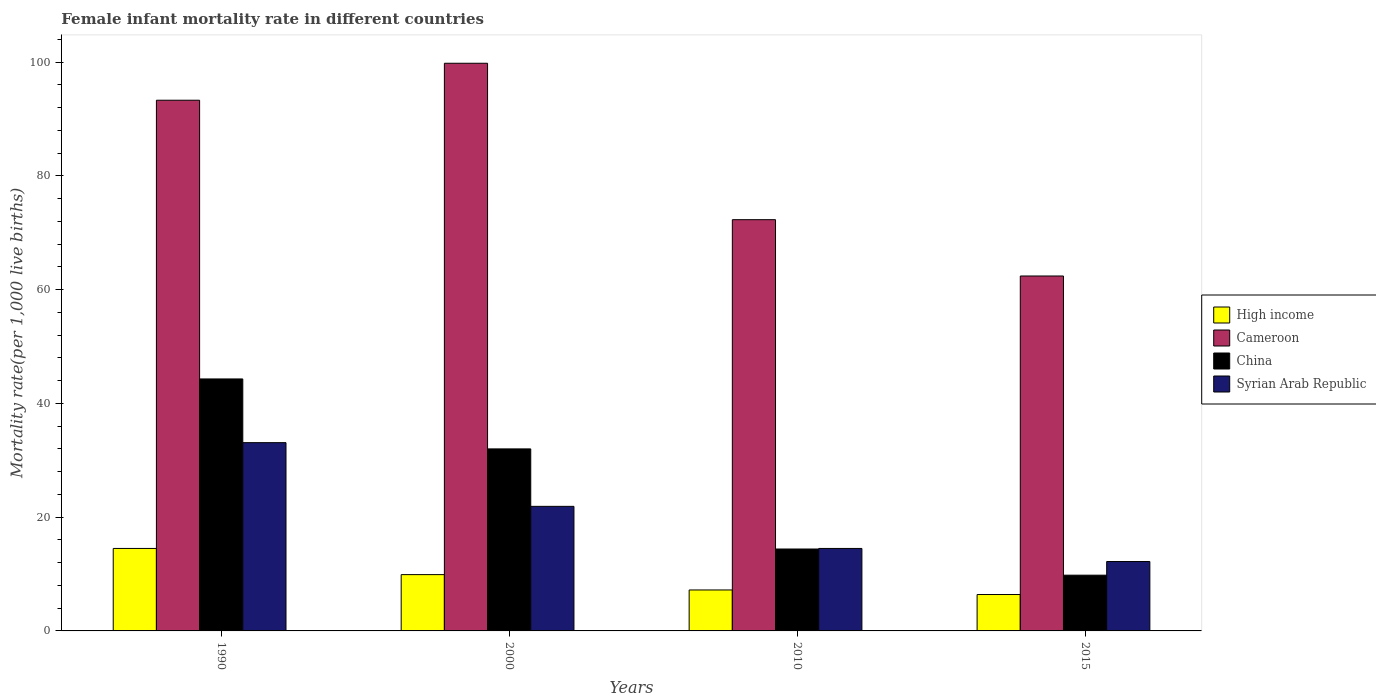Are the number of bars on each tick of the X-axis equal?
Offer a terse response. Yes. In how many cases, is the number of bars for a given year not equal to the number of legend labels?
Offer a very short reply. 0. Across all years, what is the minimum female infant mortality rate in Cameroon?
Provide a succinct answer. 62.4. In which year was the female infant mortality rate in High income minimum?
Give a very brief answer. 2015. What is the total female infant mortality rate in Syrian Arab Republic in the graph?
Provide a short and direct response. 81.7. What is the difference between the female infant mortality rate in High income in 2000 and the female infant mortality rate in Syrian Arab Republic in 1990?
Provide a succinct answer. -23.2. What is the average female infant mortality rate in Cameroon per year?
Give a very brief answer. 81.95. In the year 2000, what is the difference between the female infant mortality rate in China and female infant mortality rate in Syrian Arab Republic?
Ensure brevity in your answer.  10.1. In how many years, is the female infant mortality rate in Cameroon greater than 60?
Your answer should be very brief. 4. What is the ratio of the female infant mortality rate in China in 1990 to that in 2015?
Your answer should be compact. 4.52. Is the female infant mortality rate in Cameroon in 1990 less than that in 2010?
Your answer should be compact. No. What is the difference between the highest and the second highest female infant mortality rate in China?
Offer a very short reply. 12.3. What is the difference between the highest and the lowest female infant mortality rate in China?
Make the answer very short. 34.5. In how many years, is the female infant mortality rate in Cameroon greater than the average female infant mortality rate in Cameroon taken over all years?
Offer a terse response. 2. Is the sum of the female infant mortality rate in High income in 2000 and 2010 greater than the maximum female infant mortality rate in Syrian Arab Republic across all years?
Your response must be concise. No. Is it the case that in every year, the sum of the female infant mortality rate in Syrian Arab Republic and female infant mortality rate in High income is greater than the sum of female infant mortality rate in China and female infant mortality rate in Cameroon?
Your response must be concise. No. What does the 1st bar from the left in 2010 represents?
Your answer should be very brief. High income. Is it the case that in every year, the sum of the female infant mortality rate in High income and female infant mortality rate in Cameroon is greater than the female infant mortality rate in Syrian Arab Republic?
Ensure brevity in your answer.  Yes. Are all the bars in the graph horizontal?
Keep it short and to the point. No. How many years are there in the graph?
Provide a succinct answer. 4. What is the difference between two consecutive major ticks on the Y-axis?
Your answer should be compact. 20. Where does the legend appear in the graph?
Give a very brief answer. Center right. How are the legend labels stacked?
Provide a succinct answer. Vertical. What is the title of the graph?
Offer a terse response. Female infant mortality rate in different countries. Does "Lesotho" appear as one of the legend labels in the graph?
Keep it short and to the point. No. What is the label or title of the Y-axis?
Your response must be concise. Mortality rate(per 1,0 live births). What is the Mortality rate(per 1,000 live births) of Cameroon in 1990?
Offer a very short reply. 93.3. What is the Mortality rate(per 1,000 live births) of China in 1990?
Ensure brevity in your answer.  44.3. What is the Mortality rate(per 1,000 live births) of Syrian Arab Republic in 1990?
Your response must be concise. 33.1. What is the Mortality rate(per 1,000 live births) in High income in 2000?
Your answer should be compact. 9.9. What is the Mortality rate(per 1,000 live births) in Cameroon in 2000?
Make the answer very short. 99.8. What is the Mortality rate(per 1,000 live births) of China in 2000?
Keep it short and to the point. 32. What is the Mortality rate(per 1,000 live births) of Syrian Arab Republic in 2000?
Keep it short and to the point. 21.9. What is the Mortality rate(per 1,000 live births) of Cameroon in 2010?
Offer a very short reply. 72.3. What is the Mortality rate(per 1,000 live births) of China in 2010?
Give a very brief answer. 14.4. What is the Mortality rate(per 1,000 live births) in Cameroon in 2015?
Your response must be concise. 62.4. What is the Mortality rate(per 1,000 live births) of Syrian Arab Republic in 2015?
Offer a very short reply. 12.2. Across all years, what is the maximum Mortality rate(per 1,000 live births) of Cameroon?
Keep it short and to the point. 99.8. Across all years, what is the maximum Mortality rate(per 1,000 live births) of China?
Keep it short and to the point. 44.3. Across all years, what is the maximum Mortality rate(per 1,000 live births) in Syrian Arab Republic?
Offer a very short reply. 33.1. Across all years, what is the minimum Mortality rate(per 1,000 live births) in Cameroon?
Offer a terse response. 62.4. Across all years, what is the minimum Mortality rate(per 1,000 live births) in China?
Your response must be concise. 9.8. What is the total Mortality rate(per 1,000 live births) in Cameroon in the graph?
Your response must be concise. 327.8. What is the total Mortality rate(per 1,000 live births) of China in the graph?
Provide a short and direct response. 100.5. What is the total Mortality rate(per 1,000 live births) of Syrian Arab Republic in the graph?
Ensure brevity in your answer.  81.7. What is the difference between the Mortality rate(per 1,000 live births) of Cameroon in 1990 and that in 2000?
Provide a succinct answer. -6.5. What is the difference between the Mortality rate(per 1,000 live births) of Syrian Arab Republic in 1990 and that in 2000?
Your response must be concise. 11.2. What is the difference between the Mortality rate(per 1,000 live births) of Cameroon in 1990 and that in 2010?
Ensure brevity in your answer.  21. What is the difference between the Mortality rate(per 1,000 live births) in China in 1990 and that in 2010?
Provide a succinct answer. 29.9. What is the difference between the Mortality rate(per 1,000 live births) in High income in 1990 and that in 2015?
Your response must be concise. 8.1. What is the difference between the Mortality rate(per 1,000 live births) in Cameroon in 1990 and that in 2015?
Your response must be concise. 30.9. What is the difference between the Mortality rate(per 1,000 live births) of China in 1990 and that in 2015?
Your answer should be compact. 34.5. What is the difference between the Mortality rate(per 1,000 live births) of Syrian Arab Republic in 1990 and that in 2015?
Provide a short and direct response. 20.9. What is the difference between the Mortality rate(per 1,000 live births) of High income in 2000 and that in 2010?
Provide a succinct answer. 2.7. What is the difference between the Mortality rate(per 1,000 live births) of Syrian Arab Republic in 2000 and that in 2010?
Your response must be concise. 7.4. What is the difference between the Mortality rate(per 1,000 live births) of High income in 2000 and that in 2015?
Provide a succinct answer. 3.5. What is the difference between the Mortality rate(per 1,000 live births) in Cameroon in 2000 and that in 2015?
Your answer should be very brief. 37.4. What is the difference between the Mortality rate(per 1,000 live births) in China in 2000 and that in 2015?
Ensure brevity in your answer.  22.2. What is the difference between the Mortality rate(per 1,000 live births) in Syrian Arab Republic in 2000 and that in 2015?
Your response must be concise. 9.7. What is the difference between the Mortality rate(per 1,000 live births) of High income in 2010 and that in 2015?
Provide a succinct answer. 0.8. What is the difference between the Mortality rate(per 1,000 live births) in Cameroon in 2010 and that in 2015?
Keep it short and to the point. 9.9. What is the difference between the Mortality rate(per 1,000 live births) in China in 2010 and that in 2015?
Give a very brief answer. 4.6. What is the difference between the Mortality rate(per 1,000 live births) in Syrian Arab Republic in 2010 and that in 2015?
Keep it short and to the point. 2.3. What is the difference between the Mortality rate(per 1,000 live births) in High income in 1990 and the Mortality rate(per 1,000 live births) in Cameroon in 2000?
Your response must be concise. -85.3. What is the difference between the Mortality rate(per 1,000 live births) in High income in 1990 and the Mortality rate(per 1,000 live births) in China in 2000?
Your response must be concise. -17.5. What is the difference between the Mortality rate(per 1,000 live births) in High income in 1990 and the Mortality rate(per 1,000 live births) in Syrian Arab Republic in 2000?
Make the answer very short. -7.4. What is the difference between the Mortality rate(per 1,000 live births) of Cameroon in 1990 and the Mortality rate(per 1,000 live births) of China in 2000?
Provide a short and direct response. 61.3. What is the difference between the Mortality rate(per 1,000 live births) in Cameroon in 1990 and the Mortality rate(per 1,000 live births) in Syrian Arab Republic in 2000?
Offer a terse response. 71.4. What is the difference between the Mortality rate(per 1,000 live births) in China in 1990 and the Mortality rate(per 1,000 live births) in Syrian Arab Republic in 2000?
Provide a short and direct response. 22.4. What is the difference between the Mortality rate(per 1,000 live births) in High income in 1990 and the Mortality rate(per 1,000 live births) in Cameroon in 2010?
Your answer should be compact. -57.8. What is the difference between the Mortality rate(per 1,000 live births) of High income in 1990 and the Mortality rate(per 1,000 live births) of Syrian Arab Republic in 2010?
Offer a very short reply. 0. What is the difference between the Mortality rate(per 1,000 live births) in Cameroon in 1990 and the Mortality rate(per 1,000 live births) in China in 2010?
Your answer should be compact. 78.9. What is the difference between the Mortality rate(per 1,000 live births) of Cameroon in 1990 and the Mortality rate(per 1,000 live births) of Syrian Arab Republic in 2010?
Ensure brevity in your answer.  78.8. What is the difference between the Mortality rate(per 1,000 live births) of China in 1990 and the Mortality rate(per 1,000 live births) of Syrian Arab Republic in 2010?
Provide a short and direct response. 29.8. What is the difference between the Mortality rate(per 1,000 live births) in High income in 1990 and the Mortality rate(per 1,000 live births) in Cameroon in 2015?
Offer a very short reply. -47.9. What is the difference between the Mortality rate(per 1,000 live births) of Cameroon in 1990 and the Mortality rate(per 1,000 live births) of China in 2015?
Offer a very short reply. 83.5. What is the difference between the Mortality rate(per 1,000 live births) in Cameroon in 1990 and the Mortality rate(per 1,000 live births) in Syrian Arab Republic in 2015?
Offer a very short reply. 81.1. What is the difference between the Mortality rate(per 1,000 live births) in China in 1990 and the Mortality rate(per 1,000 live births) in Syrian Arab Republic in 2015?
Your response must be concise. 32.1. What is the difference between the Mortality rate(per 1,000 live births) in High income in 2000 and the Mortality rate(per 1,000 live births) in Cameroon in 2010?
Offer a terse response. -62.4. What is the difference between the Mortality rate(per 1,000 live births) in High income in 2000 and the Mortality rate(per 1,000 live births) in China in 2010?
Offer a very short reply. -4.5. What is the difference between the Mortality rate(per 1,000 live births) in High income in 2000 and the Mortality rate(per 1,000 live births) in Syrian Arab Republic in 2010?
Your answer should be very brief. -4.6. What is the difference between the Mortality rate(per 1,000 live births) in Cameroon in 2000 and the Mortality rate(per 1,000 live births) in China in 2010?
Offer a very short reply. 85.4. What is the difference between the Mortality rate(per 1,000 live births) in Cameroon in 2000 and the Mortality rate(per 1,000 live births) in Syrian Arab Republic in 2010?
Your response must be concise. 85.3. What is the difference between the Mortality rate(per 1,000 live births) in China in 2000 and the Mortality rate(per 1,000 live births) in Syrian Arab Republic in 2010?
Your answer should be compact. 17.5. What is the difference between the Mortality rate(per 1,000 live births) of High income in 2000 and the Mortality rate(per 1,000 live births) of Cameroon in 2015?
Your answer should be compact. -52.5. What is the difference between the Mortality rate(per 1,000 live births) of High income in 2000 and the Mortality rate(per 1,000 live births) of Syrian Arab Republic in 2015?
Provide a short and direct response. -2.3. What is the difference between the Mortality rate(per 1,000 live births) in Cameroon in 2000 and the Mortality rate(per 1,000 live births) in China in 2015?
Provide a short and direct response. 90. What is the difference between the Mortality rate(per 1,000 live births) of Cameroon in 2000 and the Mortality rate(per 1,000 live births) of Syrian Arab Republic in 2015?
Provide a short and direct response. 87.6. What is the difference between the Mortality rate(per 1,000 live births) of China in 2000 and the Mortality rate(per 1,000 live births) of Syrian Arab Republic in 2015?
Your answer should be compact. 19.8. What is the difference between the Mortality rate(per 1,000 live births) of High income in 2010 and the Mortality rate(per 1,000 live births) of Cameroon in 2015?
Provide a short and direct response. -55.2. What is the difference between the Mortality rate(per 1,000 live births) in High income in 2010 and the Mortality rate(per 1,000 live births) in China in 2015?
Provide a short and direct response. -2.6. What is the difference between the Mortality rate(per 1,000 live births) of Cameroon in 2010 and the Mortality rate(per 1,000 live births) of China in 2015?
Your answer should be very brief. 62.5. What is the difference between the Mortality rate(per 1,000 live births) in Cameroon in 2010 and the Mortality rate(per 1,000 live births) in Syrian Arab Republic in 2015?
Your answer should be compact. 60.1. What is the difference between the Mortality rate(per 1,000 live births) in China in 2010 and the Mortality rate(per 1,000 live births) in Syrian Arab Republic in 2015?
Your response must be concise. 2.2. What is the average Mortality rate(per 1,000 live births) in High income per year?
Offer a terse response. 9.5. What is the average Mortality rate(per 1,000 live births) of Cameroon per year?
Offer a terse response. 81.95. What is the average Mortality rate(per 1,000 live births) in China per year?
Keep it short and to the point. 25.12. What is the average Mortality rate(per 1,000 live births) of Syrian Arab Republic per year?
Your answer should be compact. 20.43. In the year 1990, what is the difference between the Mortality rate(per 1,000 live births) of High income and Mortality rate(per 1,000 live births) of Cameroon?
Provide a succinct answer. -78.8. In the year 1990, what is the difference between the Mortality rate(per 1,000 live births) in High income and Mortality rate(per 1,000 live births) in China?
Provide a short and direct response. -29.8. In the year 1990, what is the difference between the Mortality rate(per 1,000 live births) of High income and Mortality rate(per 1,000 live births) of Syrian Arab Republic?
Provide a succinct answer. -18.6. In the year 1990, what is the difference between the Mortality rate(per 1,000 live births) of Cameroon and Mortality rate(per 1,000 live births) of Syrian Arab Republic?
Make the answer very short. 60.2. In the year 2000, what is the difference between the Mortality rate(per 1,000 live births) in High income and Mortality rate(per 1,000 live births) in Cameroon?
Offer a very short reply. -89.9. In the year 2000, what is the difference between the Mortality rate(per 1,000 live births) in High income and Mortality rate(per 1,000 live births) in China?
Offer a terse response. -22.1. In the year 2000, what is the difference between the Mortality rate(per 1,000 live births) in Cameroon and Mortality rate(per 1,000 live births) in China?
Your response must be concise. 67.8. In the year 2000, what is the difference between the Mortality rate(per 1,000 live births) of Cameroon and Mortality rate(per 1,000 live births) of Syrian Arab Republic?
Ensure brevity in your answer.  77.9. In the year 2000, what is the difference between the Mortality rate(per 1,000 live births) in China and Mortality rate(per 1,000 live births) in Syrian Arab Republic?
Provide a short and direct response. 10.1. In the year 2010, what is the difference between the Mortality rate(per 1,000 live births) of High income and Mortality rate(per 1,000 live births) of Cameroon?
Ensure brevity in your answer.  -65.1. In the year 2010, what is the difference between the Mortality rate(per 1,000 live births) in Cameroon and Mortality rate(per 1,000 live births) in China?
Your answer should be compact. 57.9. In the year 2010, what is the difference between the Mortality rate(per 1,000 live births) of Cameroon and Mortality rate(per 1,000 live births) of Syrian Arab Republic?
Your answer should be very brief. 57.8. In the year 2010, what is the difference between the Mortality rate(per 1,000 live births) in China and Mortality rate(per 1,000 live births) in Syrian Arab Republic?
Your answer should be compact. -0.1. In the year 2015, what is the difference between the Mortality rate(per 1,000 live births) in High income and Mortality rate(per 1,000 live births) in Cameroon?
Make the answer very short. -56. In the year 2015, what is the difference between the Mortality rate(per 1,000 live births) in Cameroon and Mortality rate(per 1,000 live births) in China?
Offer a very short reply. 52.6. In the year 2015, what is the difference between the Mortality rate(per 1,000 live births) of Cameroon and Mortality rate(per 1,000 live births) of Syrian Arab Republic?
Ensure brevity in your answer.  50.2. In the year 2015, what is the difference between the Mortality rate(per 1,000 live births) in China and Mortality rate(per 1,000 live births) in Syrian Arab Republic?
Give a very brief answer. -2.4. What is the ratio of the Mortality rate(per 1,000 live births) in High income in 1990 to that in 2000?
Provide a short and direct response. 1.46. What is the ratio of the Mortality rate(per 1,000 live births) in Cameroon in 1990 to that in 2000?
Offer a very short reply. 0.93. What is the ratio of the Mortality rate(per 1,000 live births) in China in 1990 to that in 2000?
Your answer should be compact. 1.38. What is the ratio of the Mortality rate(per 1,000 live births) in Syrian Arab Republic in 1990 to that in 2000?
Give a very brief answer. 1.51. What is the ratio of the Mortality rate(per 1,000 live births) in High income in 1990 to that in 2010?
Offer a very short reply. 2.01. What is the ratio of the Mortality rate(per 1,000 live births) of Cameroon in 1990 to that in 2010?
Your answer should be compact. 1.29. What is the ratio of the Mortality rate(per 1,000 live births) of China in 1990 to that in 2010?
Offer a terse response. 3.08. What is the ratio of the Mortality rate(per 1,000 live births) of Syrian Arab Republic in 1990 to that in 2010?
Offer a very short reply. 2.28. What is the ratio of the Mortality rate(per 1,000 live births) of High income in 1990 to that in 2015?
Offer a very short reply. 2.27. What is the ratio of the Mortality rate(per 1,000 live births) in Cameroon in 1990 to that in 2015?
Your answer should be compact. 1.5. What is the ratio of the Mortality rate(per 1,000 live births) in China in 1990 to that in 2015?
Keep it short and to the point. 4.52. What is the ratio of the Mortality rate(per 1,000 live births) of Syrian Arab Republic in 1990 to that in 2015?
Offer a terse response. 2.71. What is the ratio of the Mortality rate(per 1,000 live births) in High income in 2000 to that in 2010?
Your response must be concise. 1.38. What is the ratio of the Mortality rate(per 1,000 live births) of Cameroon in 2000 to that in 2010?
Your response must be concise. 1.38. What is the ratio of the Mortality rate(per 1,000 live births) of China in 2000 to that in 2010?
Make the answer very short. 2.22. What is the ratio of the Mortality rate(per 1,000 live births) of Syrian Arab Republic in 2000 to that in 2010?
Keep it short and to the point. 1.51. What is the ratio of the Mortality rate(per 1,000 live births) in High income in 2000 to that in 2015?
Offer a very short reply. 1.55. What is the ratio of the Mortality rate(per 1,000 live births) of Cameroon in 2000 to that in 2015?
Provide a short and direct response. 1.6. What is the ratio of the Mortality rate(per 1,000 live births) in China in 2000 to that in 2015?
Your answer should be compact. 3.27. What is the ratio of the Mortality rate(per 1,000 live births) in Syrian Arab Republic in 2000 to that in 2015?
Make the answer very short. 1.8. What is the ratio of the Mortality rate(per 1,000 live births) of High income in 2010 to that in 2015?
Ensure brevity in your answer.  1.12. What is the ratio of the Mortality rate(per 1,000 live births) of Cameroon in 2010 to that in 2015?
Make the answer very short. 1.16. What is the ratio of the Mortality rate(per 1,000 live births) in China in 2010 to that in 2015?
Ensure brevity in your answer.  1.47. What is the ratio of the Mortality rate(per 1,000 live births) of Syrian Arab Republic in 2010 to that in 2015?
Provide a succinct answer. 1.19. What is the difference between the highest and the second highest Mortality rate(per 1,000 live births) in High income?
Keep it short and to the point. 4.6. What is the difference between the highest and the second highest Mortality rate(per 1,000 live births) in China?
Your response must be concise. 12.3. What is the difference between the highest and the lowest Mortality rate(per 1,000 live births) in Cameroon?
Give a very brief answer. 37.4. What is the difference between the highest and the lowest Mortality rate(per 1,000 live births) in China?
Provide a short and direct response. 34.5. What is the difference between the highest and the lowest Mortality rate(per 1,000 live births) in Syrian Arab Republic?
Your answer should be compact. 20.9. 